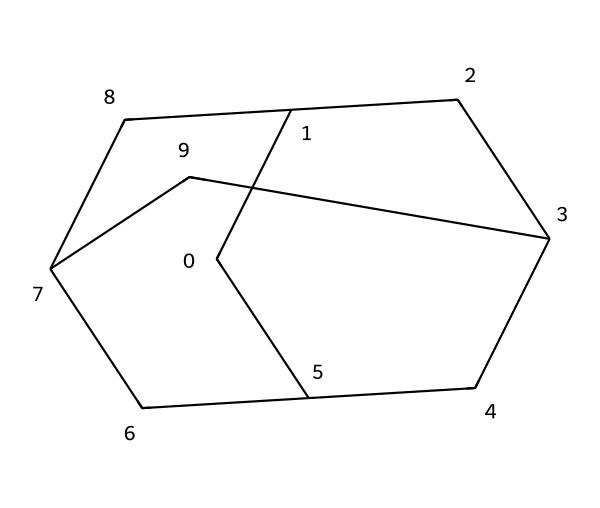What is the name of the compound represented by this structure? The SMILES representation "C1C2CC3CC1CC(C2)C3" corresponds to adamantane, which is a well-known cage hydrocarbon structure.
Answer: adamantane How many carbon atoms are in this chemical structure? By analyzing the SMILES code, we can count a total of 10 carbon atoms represented by the 'C' characters in the notation.
Answer: 10 What type of structure does adamantane have? The structure indicates a cage-like conformation due to the interconnected carbon atoms forming a three-dimensional shape.
Answer: cage-like What is the total number of hydrogen atoms in adamantane? In the structure of adamantane, each carbon atom typically bonds with two or three hydrogen atoms. The formula is C10H16, thus indicating there are 16 hydrogen atoms.
Answer: 16 Can this compound be classified as a saturated hydrocarbon? The absence of double or triple bonds and the presence of only single bonds between carbon atoms confirm that adamantane is saturated.
Answer: yes What is one common application of adamantane? Adamantane is commonly used in the formulation of weather-resistant coatings due to its stability and resistance to weathering.
Answer: coatings 